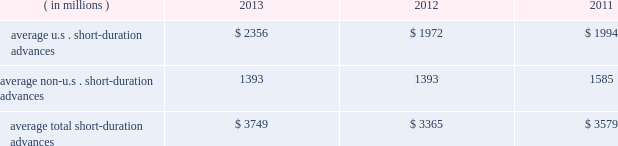Management 2019s discussion and analysis of financial condition and results of operations ( continued ) the table presents average u.s .
And non-u.s .
Short-duration advances for the years ended december 31 : years ended december 31 .
Although average short-duration advances for the year ended december 31 , 2013 increased compared to the year ended december 31 , 2012 , such average advances remained low relative to historical levels , mainly the result of clients continuing to hold higher levels of liquidity .
Average other interest-earning assets increased to $ 11.16 billion for the year ended december 31 , 2013 from $ 7.38 billion for the year ended december 31 , 2012 .
The increased levels were primarily the result of higher levels of cash collateral provided in connection with our participation in principal securities finance transactions .
Aggregate average interest-bearing deposits increased to $ 109.25 billion for the year ended december 31 , 2013 from $ 98.39 billion for the year ended december 31 , 2012 .
This increase was mainly due to higher levels of non-u.s .
Transaction accounts associated with the growth of new and existing business in assets under custody and administration .
Future transaction account levels will be influenced by the underlying asset servicing business , as well as market conditions , including the general levels of u.s .
And non-u.s .
Interest rates .
Average other short-term borrowings declined to $ 3.79 billion for the year ended december 31 , 2013 from $ 4.68 billion for the year ended december 31 , 2012 , as higher levels of client deposits provided additional liquidity .
Average long-term debt increased to $ 8.42 billion for the year ended december 31 , 2013 from $ 7.01 billion for the year ended december 31 , 2012 .
The increase primarily reflected the issuance of $ 1.0 billion of extendible notes by state street bank in december 2012 , the issuance of $ 1.5 billion of senior and subordinated debt in may 2013 , and the issuance of $ 1.0 billion of senior debt in november 2013 .
This increase was partly offset by maturities of $ 1.75 billion of senior debt in the second quarter of 2012 .
Average other interest-bearing liabilities increased to $ 6.46 billion for the year ended december 31 , 2013 from $ 5.90 billion for the year ended december 31 , 2012 , primarily the result of higher levels of cash collateral received from clients in connection with our participation in principal securities finance transactions .
Several factors could affect future levels of our net interest revenue and margin , including the mix of client liabilities ; actions of various central banks ; changes in u.s .
And non-u.s .
Interest rates ; changes in the various yield curves around the world ; revised or proposed regulatory capital or liquidity standards , or interpretations of those standards ; the amount of discount accretion generated by the former conduit securities that remain in our investment securities portfolio ; and the yields earned on securities purchased compared to the yields earned on securities sold or matured .
Based on market conditions and other factors , we continue to reinvest the majority of the proceeds from pay- downs and maturities of investment securities in highly-rated securities , such as u.s .
Treasury and agency securities , federal agency mortgage-backed securities and u.s .
And non-u.s .
Mortgage- and asset-backed securities .
The pace at which we continue to reinvest and the types of investment securities purchased will depend on the impact of market conditions and other factors over time .
We expect these factors and the levels of global interest rates to dictate what effect our reinvestment program will have on future levels of our net interest revenue and net interest margin. .
What is the growth rate of the average total short-duration advances from 2011 to 2012? 
Computations: ((3365 - 3579) / 3579)
Answer: -0.05979. 